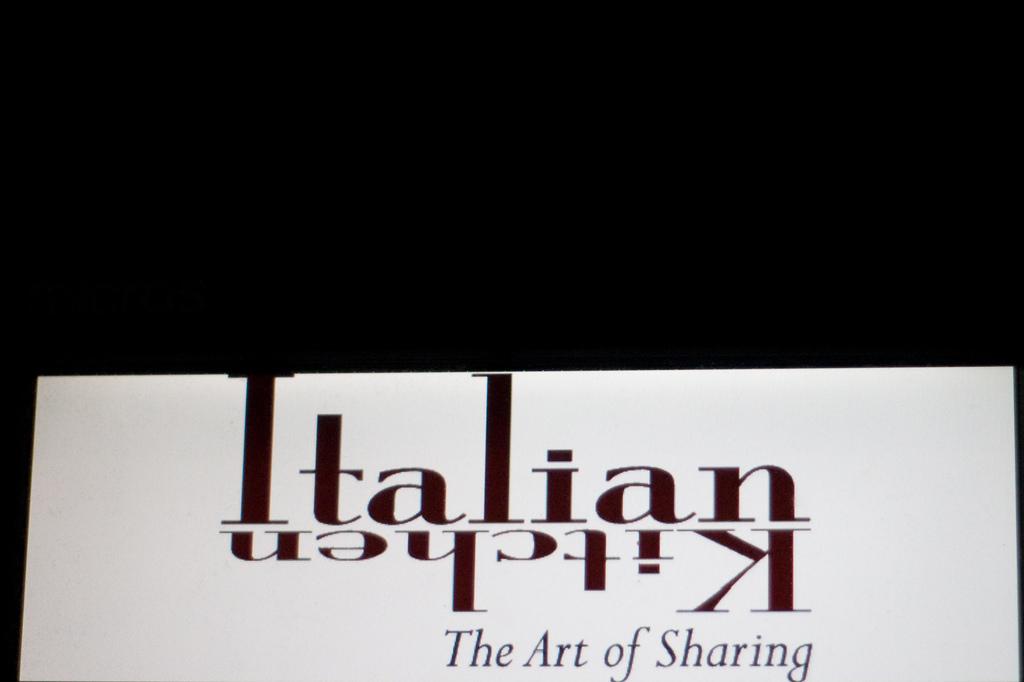What kind of art are they talking about here?
Your answer should be compact. Sharing. What is the brand name?
Offer a very short reply. Italian kitchen. 